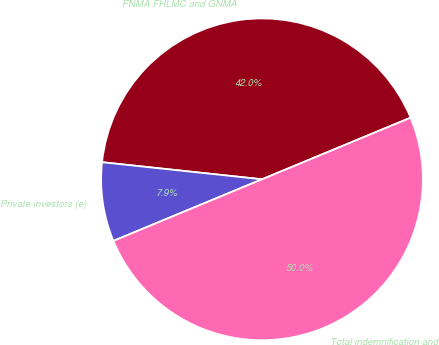Convert chart to OTSL. <chart><loc_0><loc_0><loc_500><loc_500><pie_chart><fcel>FNMA FHLMC and GNMA<fcel>Private investors (e)<fcel>Total indemnification and<nl><fcel>42.05%<fcel>7.95%<fcel>50.0%<nl></chart> 